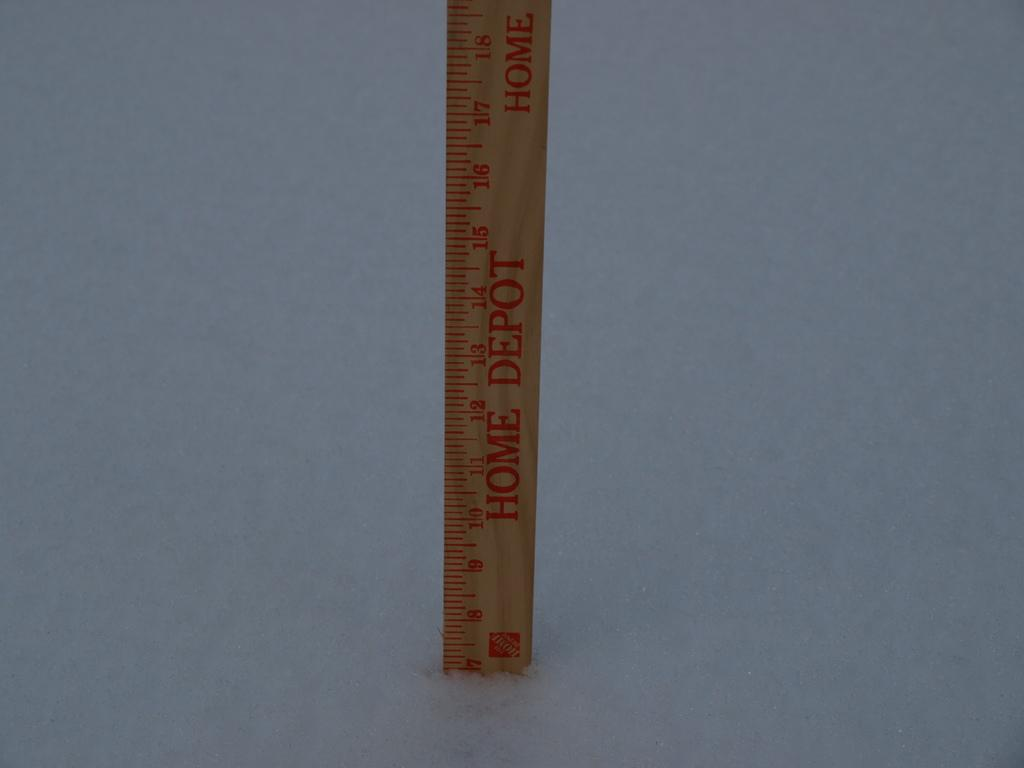Provide a one-sentence caption for the provided image. A home depot ruler sits on one end. 